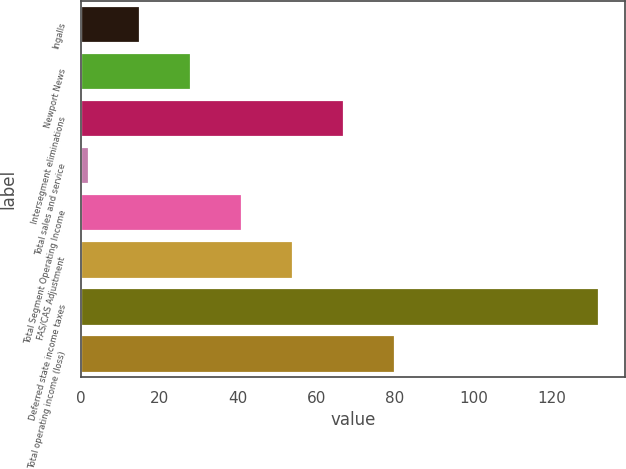Convert chart to OTSL. <chart><loc_0><loc_0><loc_500><loc_500><bar_chart><fcel>Ingalls<fcel>Newport News<fcel>Intersegment eliminations<fcel>Total sales and service<fcel>Total Segment Operating Income<fcel>FAS/CAS Adjustment<fcel>Deferred state income taxes<fcel>Total operating income (loss)<nl><fcel>15<fcel>28<fcel>67<fcel>2<fcel>41<fcel>54<fcel>132<fcel>80<nl></chart> 